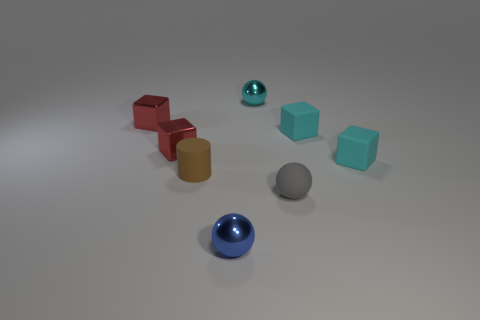Can you describe the lighting and shadows in the scene? The lighting in the image is diffuse, casting soft shadows to the right of the objects. This gentle light creates a calm atmosphere and enhances the three-dimensional quality of the items. 